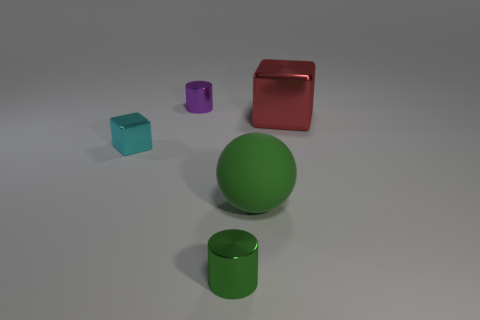Add 2 big green objects. How many objects exist? 7 Subtract all cubes. How many objects are left? 3 Subtract 2 cylinders. How many cylinders are left? 0 Subtract all large gray blocks. Subtract all red things. How many objects are left? 4 Add 4 large red cubes. How many large red cubes are left? 5 Add 5 large spheres. How many large spheres exist? 6 Subtract 0 yellow cubes. How many objects are left? 5 Subtract all gray cylinders. Subtract all green cubes. How many cylinders are left? 2 